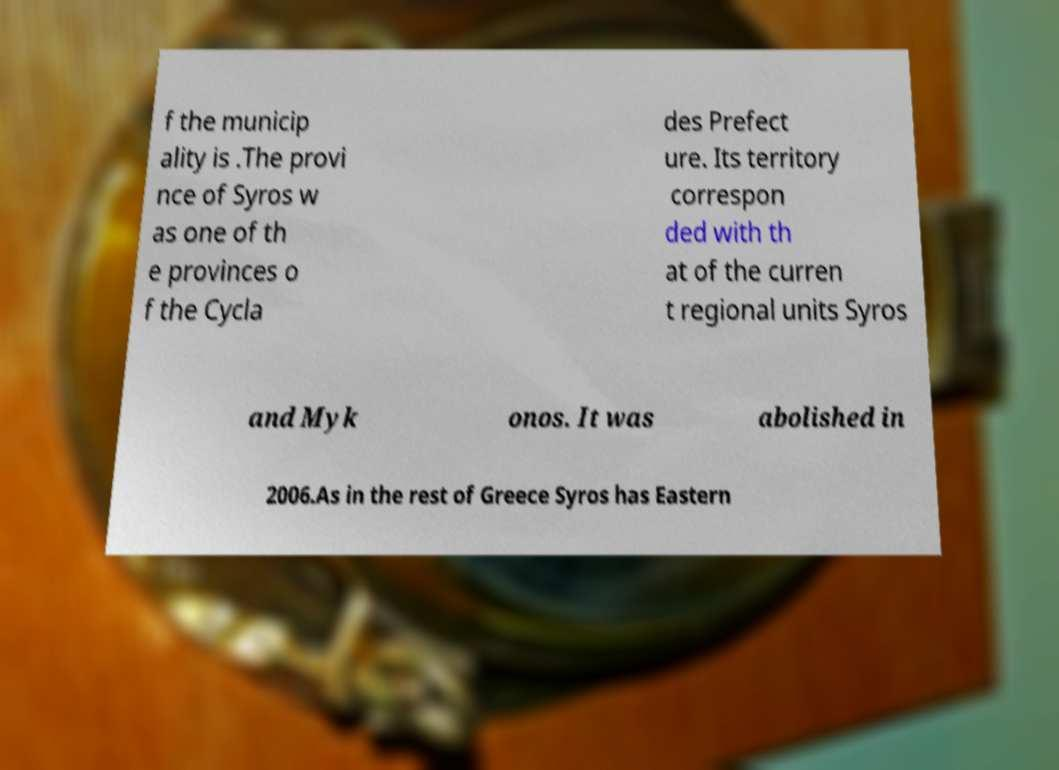Can you read and provide the text displayed in the image?This photo seems to have some interesting text. Can you extract and type it out for me? f the municip ality is .The provi nce of Syros w as one of th e provinces o f the Cycla des Prefect ure. Its territory correspon ded with th at of the curren t regional units Syros and Myk onos. It was abolished in 2006.As in the rest of Greece Syros has Eastern 